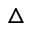<formula> <loc_0><loc_0><loc_500><loc_500>\triangle</formula> 